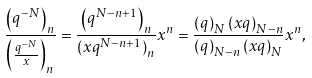Convert formula to latex. <formula><loc_0><loc_0><loc_500><loc_500>\frac { \left ( q ^ { - N } \right ) _ { n } } { \left ( \frac { q ^ { - N } } { x } \right ) _ { n } } = \frac { \left ( q ^ { N - n + 1 } \right ) _ { n } } { \left ( x q ^ { N - n + 1 } \right ) _ { n } } x ^ { n } = \frac { \left ( q \right ) _ { N } \left ( x q \right ) _ { N - n } } { \left ( q \right ) _ { N - n } \left ( x q \right ) _ { N } } x ^ { n } ,</formula> 